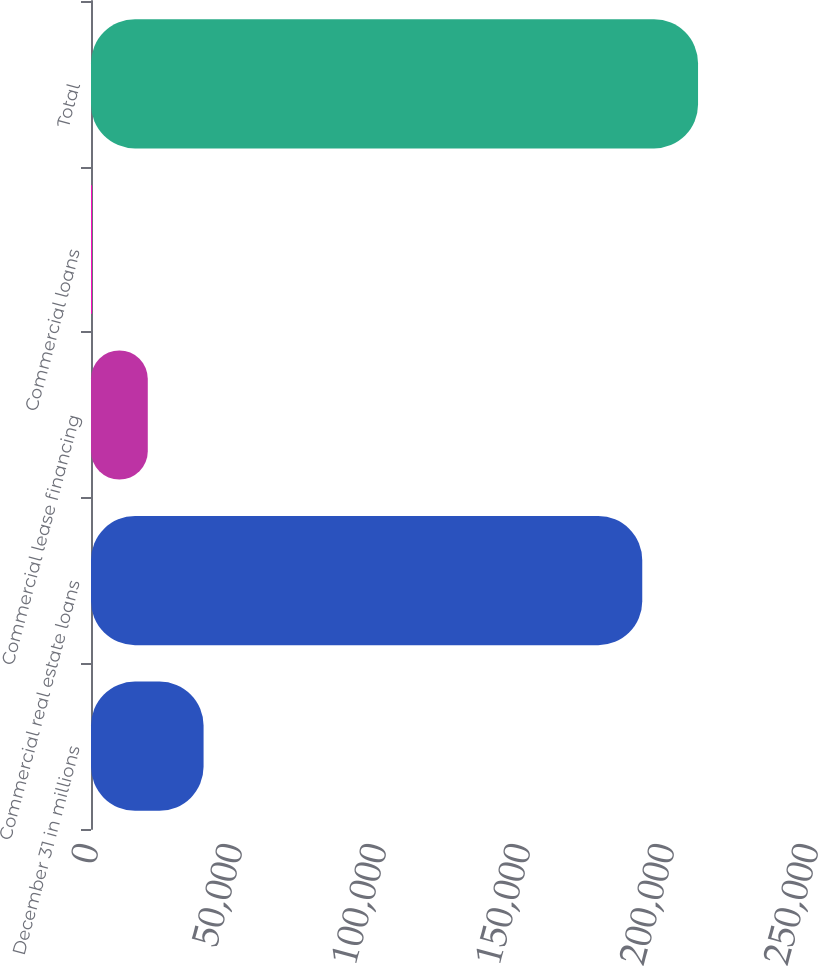<chart> <loc_0><loc_0><loc_500><loc_500><bar_chart><fcel>December 31 in millions<fcel>Commercial real estate loans<fcel>Commercial lease financing<fcel>Commercial loans<fcel>Total<nl><fcel>39087.6<fcel>191407<fcel>19715.8<fcel>344<fcel>210779<nl></chart> 